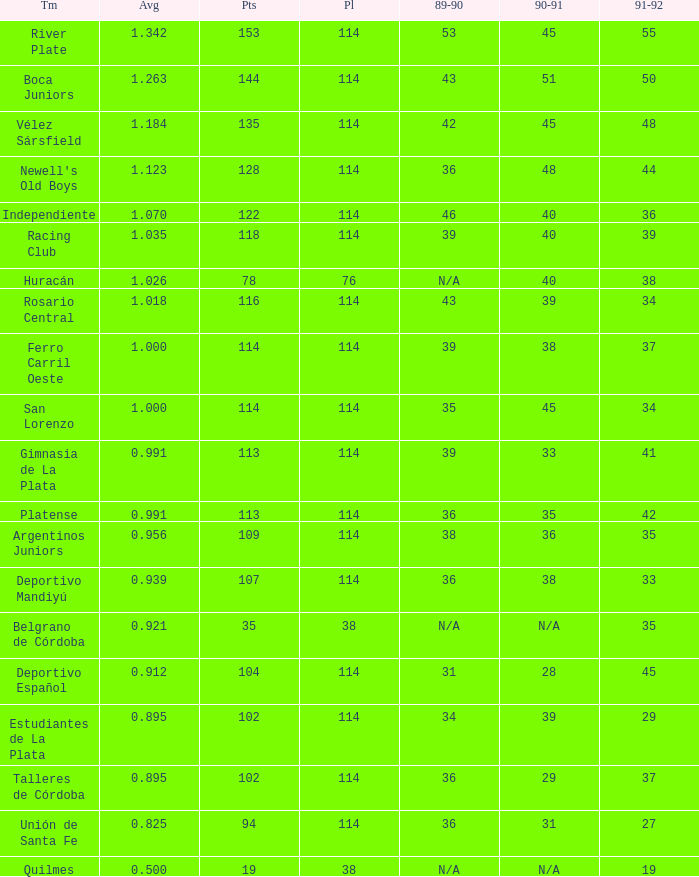How much Average has a 1989-90 of 36, and a Team of talleres de córdoba, and a Played smaller than 114? 0.0. Write the full table. {'header': ['Tm', 'Avg', 'Pts', 'Pl', '89-90', '90-91', '91-92'], 'rows': [['River Plate', '1.342', '153', '114', '53', '45', '55'], ['Boca Juniors', '1.263', '144', '114', '43', '51', '50'], ['Vélez Sársfield', '1.184', '135', '114', '42', '45', '48'], ["Newell's Old Boys", '1.123', '128', '114', '36', '48', '44'], ['Independiente', '1.070', '122', '114', '46', '40', '36'], ['Racing Club', '1.035', '118', '114', '39', '40', '39'], ['Huracán', '1.026', '78', '76', 'N/A', '40', '38'], ['Rosario Central', '1.018', '116', '114', '43', '39', '34'], ['Ferro Carril Oeste', '1.000', '114', '114', '39', '38', '37'], ['San Lorenzo', '1.000', '114', '114', '35', '45', '34'], ['Gimnasia de La Plata', '0.991', '113', '114', '39', '33', '41'], ['Platense', '0.991', '113', '114', '36', '35', '42'], ['Argentinos Juniors', '0.956', '109', '114', '38', '36', '35'], ['Deportivo Mandiyú', '0.939', '107', '114', '36', '38', '33'], ['Belgrano de Córdoba', '0.921', '35', '38', 'N/A', 'N/A', '35'], ['Deportivo Español', '0.912', '104', '114', '31', '28', '45'], ['Estudiantes de La Plata', '0.895', '102', '114', '34', '39', '29'], ['Talleres de Córdoba', '0.895', '102', '114', '36', '29', '37'], ['Unión de Santa Fe', '0.825', '94', '114', '36', '31', '27'], ['Quilmes', '0.500', '19', '38', 'N/A', 'N/A', '19']]} 